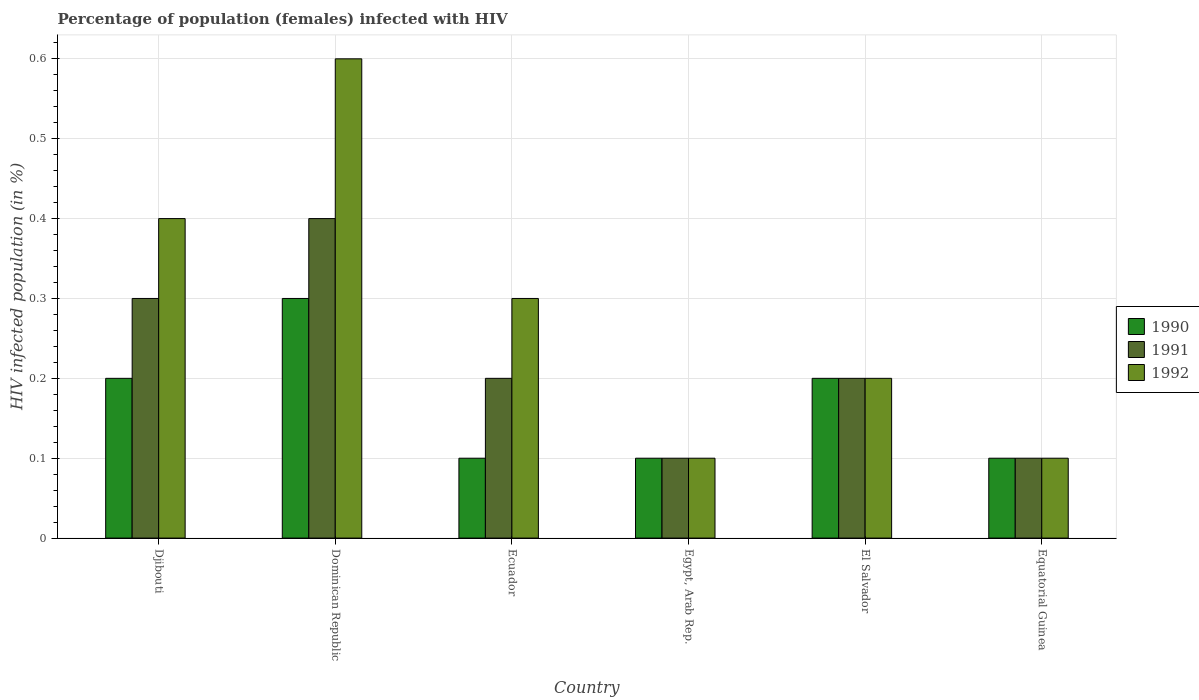How many different coloured bars are there?
Your response must be concise. 3. Are the number of bars per tick equal to the number of legend labels?
Offer a terse response. Yes. What is the label of the 2nd group of bars from the left?
Give a very brief answer. Dominican Republic. What is the percentage of HIV infected female population in 1990 in Ecuador?
Your answer should be very brief. 0.1. Across all countries, what is the minimum percentage of HIV infected female population in 1991?
Your answer should be compact. 0.1. In which country was the percentage of HIV infected female population in 1990 maximum?
Ensure brevity in your answer.  Dominican Republic. In which country was the percentage of HIV infected female population in 1992 minimum?
Your answer should be compact. Egypt, Arab Rep. What is the total percentage of HIV infected female population in 1992 in the graph?
Provide a short and direct response. 1.7. What is the difference between the percentage of HIV infected female population in 1991 in Dominican Republic and that in Egypt, Arab Rep.?
Your response must be concise. 0.3. What is the difference between the percentage of HIV infected female population in 1990 in El Salvador and the percentage of HIV infected female population in 1992 in Dominican Republic?
Give a very brief answer. -0.4. What is the average percentage of HIV infected female population in 1992 per country?
Offer a very short reply. 0.28. What is the difference between the percentage of HIV infected female population of/in 1991 and percentage of HIV infected female population of/in 1992 in Ecuador?
Offer a very short reply. -0.1. What is the difference between the highest and the second highest percentage of HIV infected female population in 1992?
Provide a short and direct response. 0.2. What is the difference between the highest and the lowest percentage of HIV infected female population in 1990?
Give a very brief answer. 0.2. In how many countries, is the percentage of HIV infected female population in 1991 greater than the average percentage of HIV infected female population in 1991 taken over all countries?
Make the answer very short. 2. What does the 2nd bar from the right in Dominican Republic represents?
Provide a short and direct response. 1991. What is the difference between two consecutive major ticks on the Y-axis?
Make the answer very short. 0.1. Are the values on the major ticks of Y-axis written in scientific E-notation?
Your answer should be very brief. No. Does the graph contain any zero values?
Keep it short and to the point. No. Where does the legend appear in the graph?
Offer a very short reply. Center right. How many legend labels are there?
Offer a very short reply. 3. What is the title of the graph?
Offer a terse response. Percentage of population (females) infected with HIV. Does "1992" appear as one of the legend labels in the graph?
Keep it short and to the point. Yes. What is the label or title of the Y-axis?
Your response must be concise. HIV infected population (in %). What is the HIV infected population (in %) of 1990 in Djibouti?
Your response must be concise. 0.2. What is the HIV infected population (in %) of 1992 in Djibouti?
Offer a very short reply. 0.4. What is the HIV infected population (in %) of 1991 in Dominican Republic?
Keep it short and to the point. 0.4. What is the HIV infected population (in %) of 1990 in Egypt, Arab Rep.?
Your answer should be very brief. 0.1. What is the HIV infected population (in %) in 1992 in El Salvador?
Your response must be concise. 0.2. What is the HIV infected population (in %) of 1990 in Equatorial Guinea?
Make the answer very short. 0.1. What is the HIV infected population (in %) in 1991 in Equatorial Guinea?
Offer a terse response. 0.1. Across all countries, what is the maximum HIV infected population (in %) of 1991?
Keep it short and to the point. 0.4. Across all countries, what is the minimum HIV infected population (in %) in 1990?
Give a very brief answer. 0.1. Across all countries, what is the minimum HIV infected population (in %) of 1991?
Give a very brief answer. 0.1. What is the total HIV infected population (in %) in 1990 in the graph?
Provide a succinct answer. 1. What is the total HIV infected population (in %) in 1991 in the graph?
Keep it short and to the point. 1.3. What is the difference between the HIV infected population (in %) in 1991 in Djibouti and that in Dominican Republic?
Give a very brief answer. -0.1. What is the difference between the HIV infected population (in %) of 1992 in Djibouti and that in Dominican Republic?
Your answer should be compact. -0.2. What is the difference between the HIV infected population (in %) of 1990 in Djibouti and that in Ecuador?
Provide a succinct answer. 0.1. What is the difference between the HIV infected population (in %) in 1990 in Djibouti and that in Egypt, Arab Rep.?
Offer a terse response. 0.1. What is the difference between the HIV infected population (in %) of 1990 in Djibouti and that in El Salvador?
Ensure brevity in your answer.  0. What is the difference between the HIV infected population (in %) of 1990 in Djibouti and that in Equatorial Guinea?
Give a very brief answer. 0.1. What is the difference between the HIV infected population (in %) in 1992 in Djibouti and that in Equatorial Guinea?
Your answer should be very brief. 0.3. What is the difference between the HIV infected population (in %) in 1990 in Dominican Republic and that in Egypt, Arab Rep.?
Provide a succinct answer. 0.2. What is the difference between the HIV infected population (in %) of 1991 in Dominican Republic and that in Egypt, Arab Rep.?
Give a very brief answer. 0.3. What is the difference between the HIV infected population (in %) of 1991 in Dominican Republic and that in Equatorial Guinea?
Make the answer very short. 0.3. What is the difference between the HIV infected population (in %) in 1992 in Dominican Republic and that in Equatorial Guinea?
Your answer should be compact. 0.5. What is the difference between the HIV infected population (in %) in 1991 in Ecuador and that in Egypt, Arab Rep.?
Give a very brief answer. 0.1. What is the difference between the HIV infected population (in %) of 1990 in Ecuador and that in El Salvador?
Offer a terse response. -0.1. What is the difference between the HIV infected population (in %) of 1991 in Ecuador and that in Equatorial Guinea?
Your answer should be compact. 0.1. What is the difference between the HIV infected population (in %) in 1991 in Egypt, Arab Rep. and that in El Salvador?
Your answer should be very brief. -0.1. What is the difference between the HIV infected population (in %) of 1992 in Egypt, Arab Rep. and that in El Salvador?
Provide a short and direct response. -0.1. What is the difference between the HIV infected population (in %) in 1990 in El Salvador and that in Equatorial Guinea?
Ensure brevity in your answer.  0.1. What is the difference between the HIV infected population (in %) in 1991 in El Salvador and that in Equatorial Guinea?
Provide a succinct answer. 0.1. What is the difference between the HIV infected population (in %) of 1992 in El Salvador and that in Equatorial Guinea?
Keep it short and to the point. 0.1. What is the difference between the HIV infected population (in %) of 1990 in Djibouti and the HIV infected population (in %) of 1992 in Dominican Republic?
Give a very brief answer. -0.4. What is the difference between the HIV infected population (in %) in 1991 in Djibouti and the HIV infected population (in %) in 1992 in Dominican Republic?
Ensure brevity in your answer.  -0.3. What is the difference between the HIV infected population (in %) in 1990 in Djibouti and the HIV infected population (in %) in 1992 in Ecuador?
Give a very brief answer. -0.1. What is the difference between the HIV infected population (in %) in 1991 in Djibouti and the HIV infected population (in %) in 1992 in Ecuador?
Offer a terse response. 0. What is the difference between the HIV infected population (in %) of 1990 in Djibouti and the HIV infected population (in %) of 1991 in Egypt, Arab Rep.?
Keep it short and to the point. 0.1. What is the difference between the HIV infected population (in %) of 1990 in Djibouti and the HIV infected population (in %) of 1992 in Egypt, Arab Rep.?
Give a very brief answer. 0.1. What is the difference between the HIV infected population (in %) of 1990 in Djibouti and the HIV infected population (in %) of 1991 in El Salvador?
Ensure brevity in your answer.  0. What is the difference between the HIV infected population (in %) in 1990 in Djibouti and the HIV infected population (in %) in 1992 in El Salvador?
Give a very brief answer. 0. What is the difference between the HIV infected population (in %) of 1991 in Djibouti and the HIV infected population (in %) of 1992 in El Salvador?
Your response must be concise. 0.1. What is the difference between the HIV infected population (in %) in 1990 in Dominican Republic and the HIV infected population (in %) in 1991 in Ecuador?
Ensure brevity in your answer.  0.1. What is the difference between the HIV infected population (in %) in 1990 in Dominican Republic and the HIV infected population (in %) in 1992 in Ecuador?
Your response must be concise. 0. What is the difference between the HIV infected population (in %) of 1990 in Dominican Republic and the HIV infected population (in %) of 1991 in Egypt, Arab Rep.?
Offer a terse response. 0.2. What is the difference between the HIV infected population (in %) in 1990 in Dominican Republic and the HIV infected population (in %) in 1991 in El Salvador?
Your response must be concise. 0.1. What is the difference between the HIV infected population (in %) in 1990 in Dominican Republic and the HIV infected population (in %) in 1992 in El Salvador?
Give a very brief answer. 0.1. What is the difference between the HIV infected population (in %) of 1991 in Dominican Republic and the HIV infected population (in %) of 1992 in El Salvador?
Your answer should be compact. 0.2. What is the difference between the HIV infected population (in %) of 1990 in Dominican Republic and the HIV infected population (in %) of 1992 in Equatorial Guinea?
Your response must be concise. 0.2. What is the difference between the HIV infected population (in %) in 1990 in Ecuador and the HIV infected population (in %) in 1992 in Egypt, Arab Rep.?
Give a very brief answer. 0. What is the difference between the HIV infected population (in %) in 1991 in Ecuador and the HIV infected population (in %) in 1992 in Egypt, Arab Rep.?
Provide a short and direct response. 0.1. What is the difference between the HIV infected population (in %) of 1990 in Ecuador and the HIV infected population (in %) of 1991 in El Salvador?
Your response must be concise. -0.1. What is the difference between the HIV infected population (in %) in 1990 in Ecuador and the HIV infected population (in %) in 1992 in El Salvador?
Offer a terse response. -0.1. What is the difference between the HIV infected population (in %) in 1991 in Ecuador and the HIV infected population (in %) in 1992 in El Salvador?
Offer a very short reply. 0. What is the difference between the HIV infected population (in %) in 1990 in Ecuador and the HIV infected population (in %) in 1992 in Equatorial Guinea?
Provide a short and direct response. 0. What is the difference between the HIV infected population (in %) of 1991 in Ecuador and the HIV infected population (in %) of 1992 in Equatorial Guinea?
Provide a short and direct response. 0.1. What is the difference between the HIV infected population (in %) in 1991 in Egypt, Arab Rep. and the HIV infected population (in %) in 1992 in El Salvador?
Make the answer very short. -0.1. What is the difference between the HIV infected population (in %) of 1990 in Egypt, Arab Rep. and the HIV infected population (in %) of 1992 in Equatorial Guinea?
Provide a succinct answer. 0. What is the difference between the HIV infected population (in %) in 1991 in El Salvador and the HIV infected population (in %) in 1992 in Equatorial Guinea?
Your answer should be compact. 0.1. What is the average HIV infected population (in %) in 1990 per country?
Your response must be concise. 0.17. What is the average HIV infected population (in %) of 1991 per country?
Offer a terse response. 0.22. What is the average HIV infected population (in %) of 1992 per country?
Provide a short and direct response. 0.28. What is the difference between the HIV infected population (in %) in 1990 and HIV infected population (in %) in 1991 in Dominican Republic?
Provide a succinct answer. -0.1. What is the difference between the HIV infected population (in %) of 1990 and HIV infected population (in %) of 1992 in Dominican Republic?
Provide a succinct answer. -0.3. What is the difference between the HIV infected population (in %) in 1991 and HIV infected population (in %) in 1992 in Dominican Republic?
Ensure brevity in your answer.  -0.2. What is the difference between the HIV infected population (in %) of 1991 and HIV infected population (in %) of 1992 in Ecuador?
Provide a short and direct response. -0.1. What is the difference between the HIV infected population (in %) of 1990 and HIV infected population (in %) of 1991 in Egypt, Arab Rep.?
Your answer should be compact. 0. What is the difference between the HIV infected population (in %) in 1990 and HIV infected population (in %) in 1992 in Egypt, Arab Rep.?
Give a very brief answer. 0. What is the difference between the HIV infected population (in %) in 1991 and HIV infected population (in %) in 1992 in Equatorial Guinea?
Give a very brief answer. 0. What is the ratio of the HIV infected population (in %) in 1992 in Djibouti to that in Dominican Republic?
Your answer should be compact. 0.67. What is the ratio of the HIV infected population (in %) in 1992 in Djibouti to that in Ecuador?
Keep it short and to the point. 1.33. What is the ratio of the HIV infected population (in %) in 1991 in Djibouti to that in Egypt, Arab Rep.?
Provide a succinct answer. 3. What is the ratio of the HIV infected population (in %) in 1992 in Djibouti to that in Egypt, Arab Rep.?
Your answer should be compact. 4. What is the ratio of the HIV infected population (in %) in 1990 in Djibouti to that in El Salvador?
Offer a very short reply. 1. What is the ratio of the HIV infected population (in %) of 1992 in Djibouti to that in El Salvador?
Make the answer very short. 2. What is the ratio of the HIV infected population (in %) of 1991 in Djibouti to that in Equatorial Guinea?
Make the answer very short. 3. What is the ratio of the HIV infected population (in %) in 1992 in Dominican Republic to that in Ecuador?
Provide a succinct answer. 2. What is the ratio of the HIV infected population (in %) in 1992 in Dominican Republic to that in Egypt, Arab Rep.?
Your answer should be compact. 6. What is the ratio of the HIV infected population (in %) in 1991 in Dominican Republic to that in El Salvador?
Give a very brief answer. 2. What is the ratio of the HIV infected population (in %) in 1992 in Dominican Republic to that in El Salvador?
Your answer should be very brief. 3. What is the ratio of the HIV infected population (in %) in 1990 in Dominican Republic to that in Equatorial Guinea?
Make the answer very short. 3. What is the ratio of the HIV infected population (in %) of 1991 in Dominican Republic to that in Equatorial Guinea?
Your answer should be compact. 4. What is the ratio of the HIV infected population (in %) of 1990 in Ecuador to that in Egypt, Arab Rep.?
Offer a very short reply. 1. What is the ratio of the HIV infected population (in %) of 1991 in Ecuador to that in Egypt, Arab Rep.?
Your answer should be very brief. 2. What is the ratio of the HIV infected population (in %) in 1990 in Ecuador to that in El Salvador?
Your response must be concise. 0.5. What is the ratio of the HIV infected population (in %) in 1990 in Ecuador to that in Equatorial Guinea?
Provide a succinct answer. 1. What is the ratio of the HIV infected population (in %) of 1991 in Ecuador to that in Equatorial Guinea?
Your answer should be very brief. 2. What is the ratio of the HIV infected population (in %) of 1992 in Ecuador to that in Equatorial Guinea?
Ensure brevity in your answer.  3. What is the ratio of the HIV infected population (in %) in 1992 in Egypt, Arab Rep. to that in El Salvador?
Provide a short and direct response. 0.5. What is the ratio of the HIV infected population (in %) in 1991 in Egypt, Arab Rep. to that in Equatorial Guinea?
Offer a very short reply. 1. What is the ratio of the HIV infected population (in %) of 1992 in Egypt, Arab Rep. to that in Equatorial Guinea?
Offer a terse response. 1. What is the difference between the highest and the second highest HIV infected population (in %) in 1990?
Give a very brief answer. 0.1. What is the difference between the highest and the lowest HIV infected population (in %) in 1992?
Ensure brevity in your answer.  0.5. 